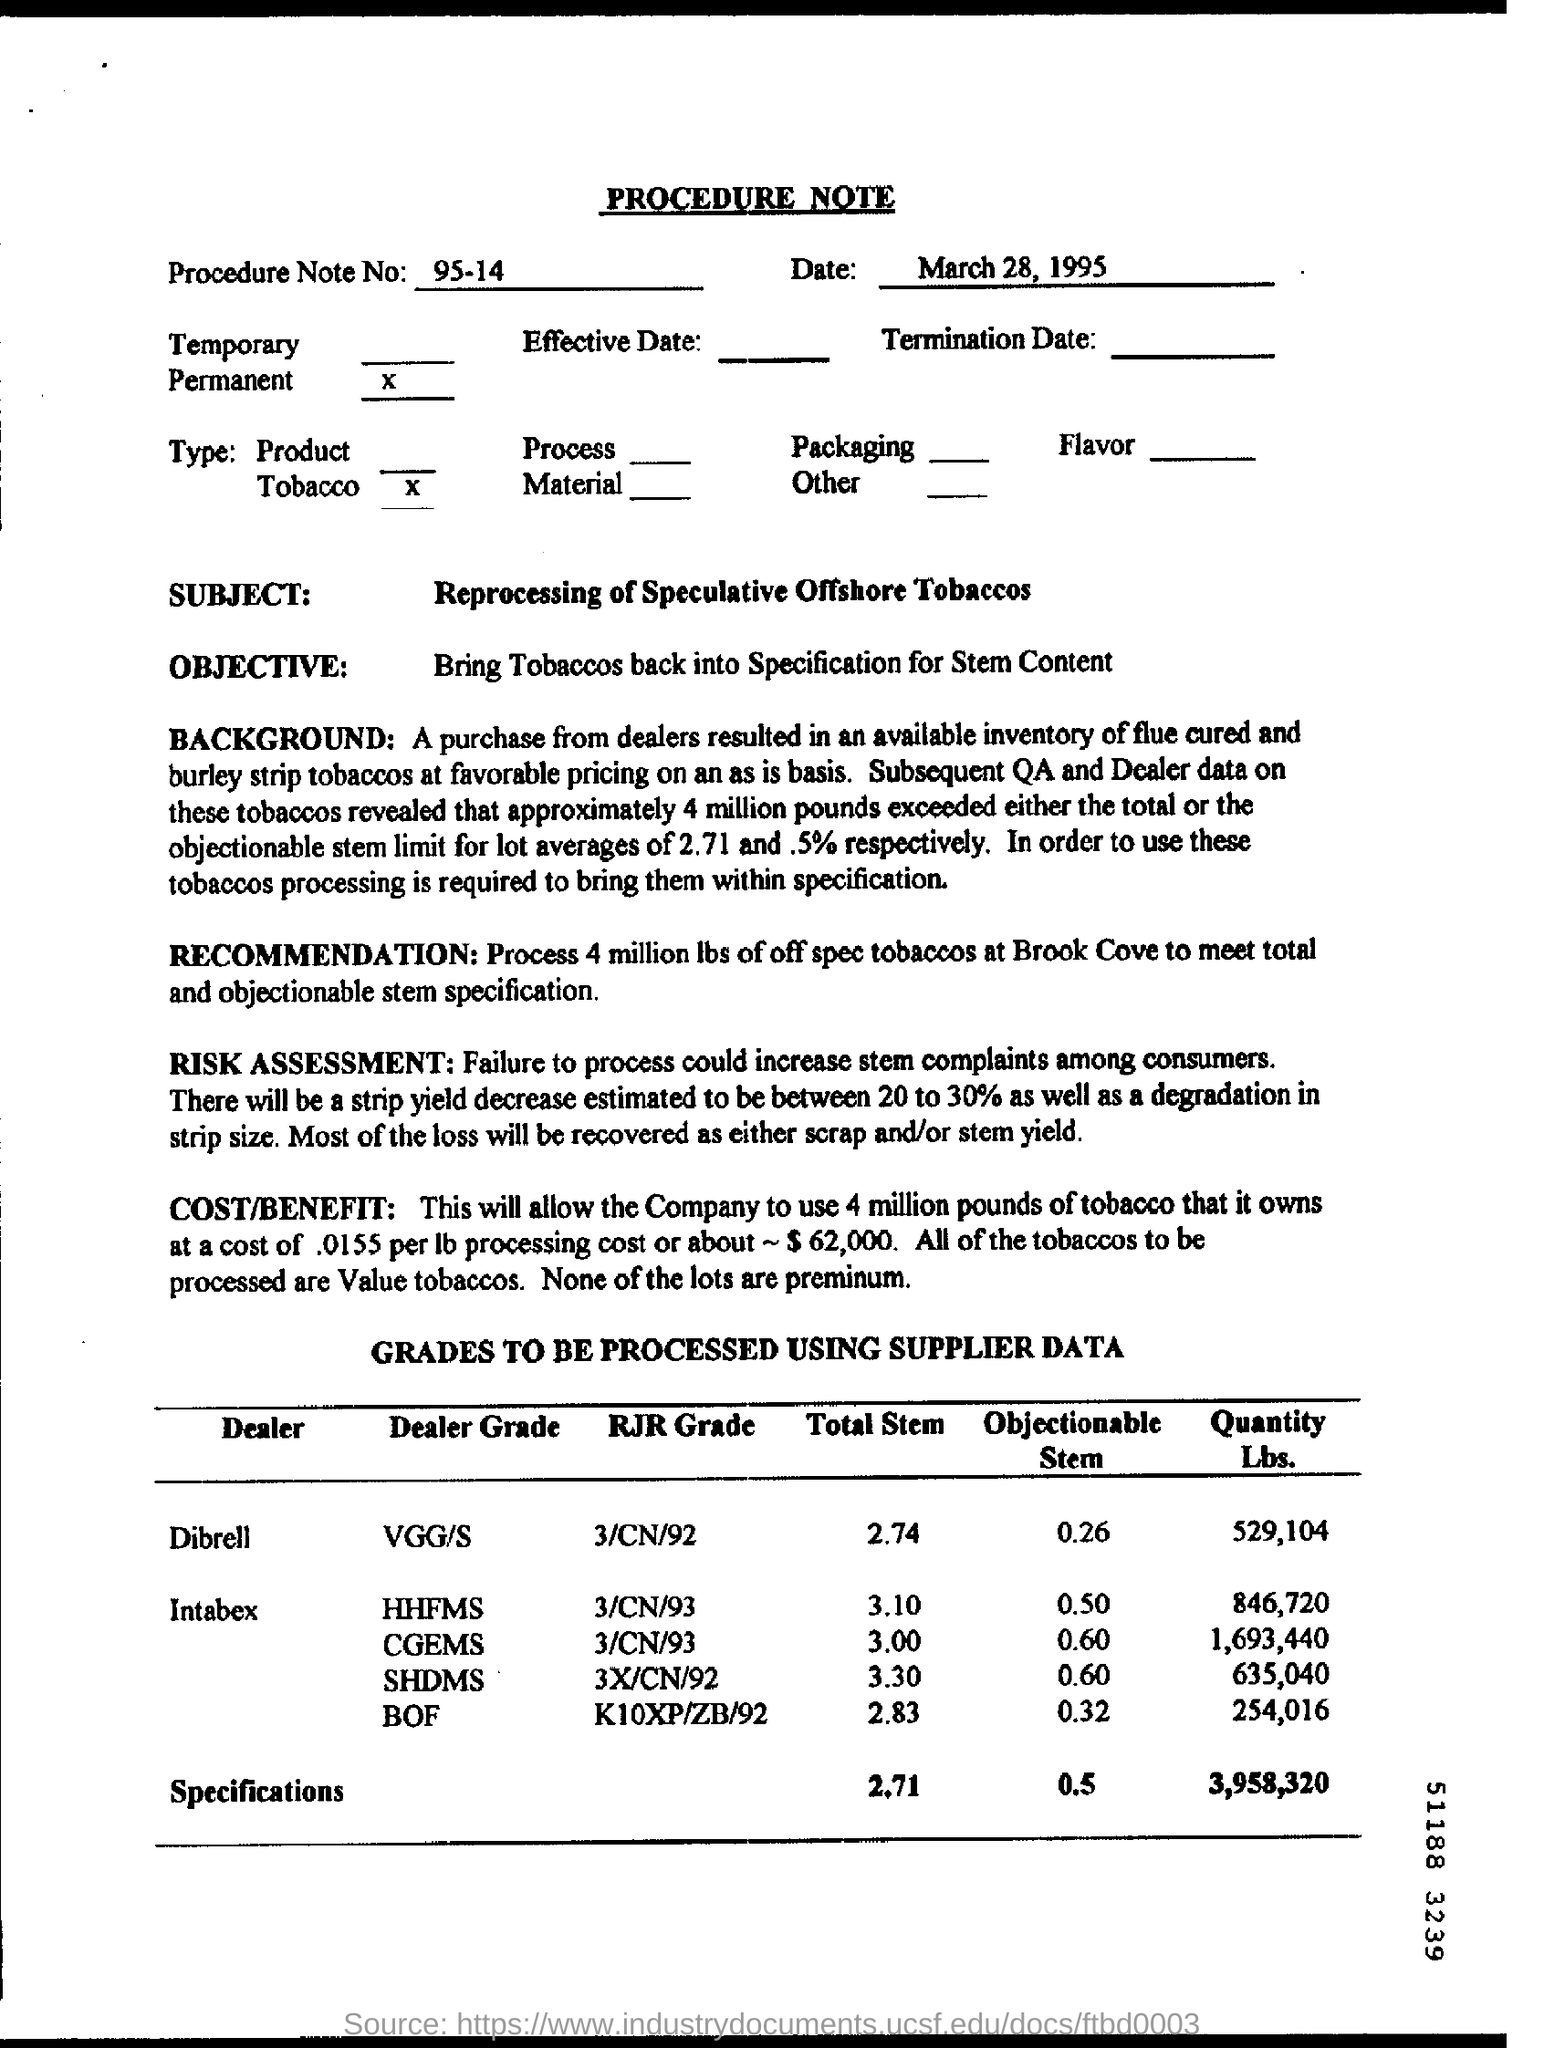What specific details are provided about the grades of tobacco to be processed? The document outlines specific dealer and RJR grades of tobacco, like VGGS, HHFMS, CGEMS, SHDMS, and BOF, along with their total stem measurements and the quantity in pounds. The objectionable stem averages are listed, and the total quantity of tobacco in question is 3,958,320 pounds. 